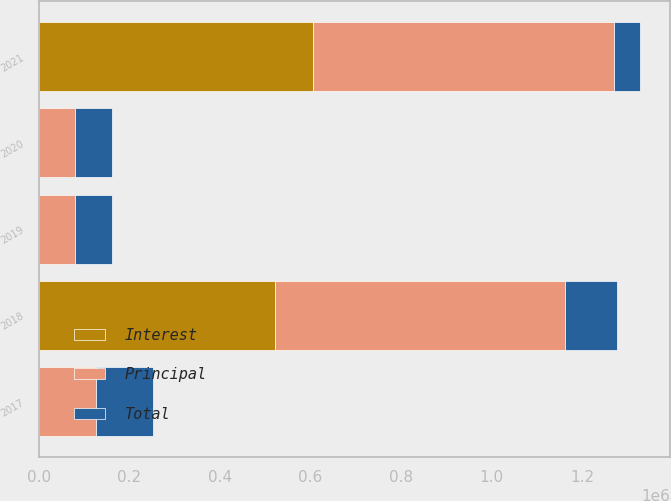Convert chart. <chart><loc_0><loc_0><loc_500><loc_500><stacked_bar_chart><ecel><fcel>2017<fcel>2018<fcel>2019<fcel>2020<fcel>2021<nl><fcel>Principal<fcel>125878<fcel>638725<fcel>80740<fcel>80741<fcel>664174<nl><fcel>Interest<fcel>138<fcel>522531<fcel>23<fcel>25<fcel>606026<nl><fcel>Total<fcel>125740<fcel>116194<fcel>80717<fcel>80716<fcel>58148<nl></chart> 